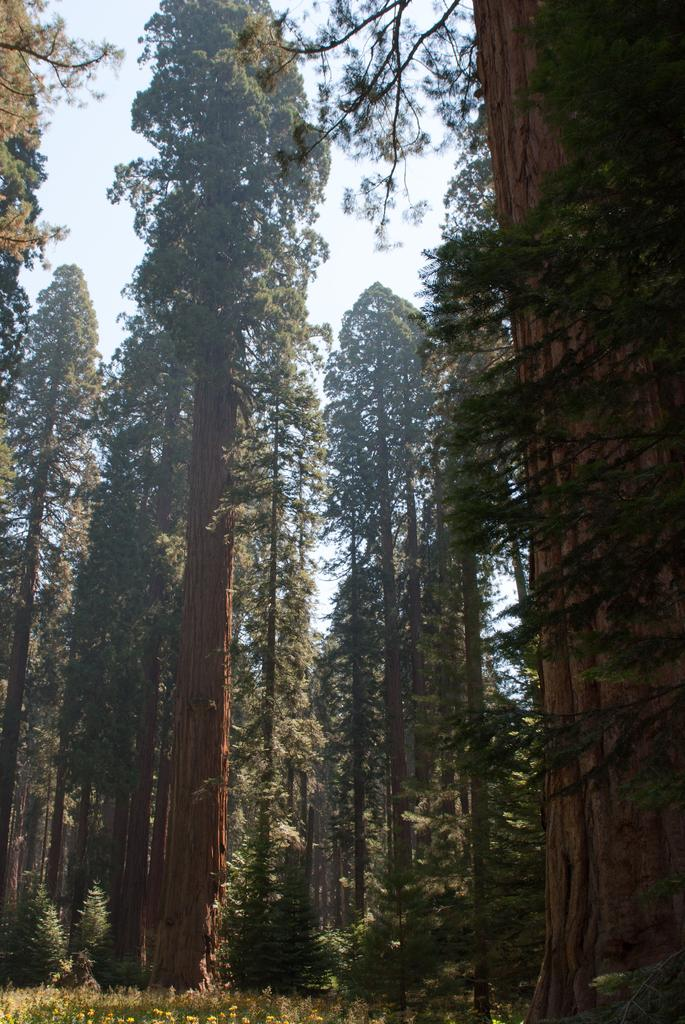What type of vegetation can be seen in the image? There are trees in the image. What type of flora is also present in the image? There are flowers in the image. What part of the natural environment is visible in the image? The sky is visible in the background of the image. What type of coast can be seen in the image? There is no coast present in the image; it features trees, flowers, and the sky. What type of account is being discussed in the image? There is no account or financial discussion present in the image. 